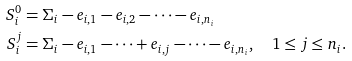Convert formula to latex. <formula><loc_0><loc_0><loc_500><loc_500>S _ { i } ^ { 0 } & = \Sigma _ { i } - e _ { i , 1 } - e _ { i , 2 } - \dots - e _ { i , n _ { i } } \\ S _ { i } ^ { j } & = \Sigma _ { i } - e _ { i , 1 } - \dots + e _ { i , j } - \dots - e _ { i , n _ { i } } , \quad 1 \leq j \leq n _ { i } .</formula> 